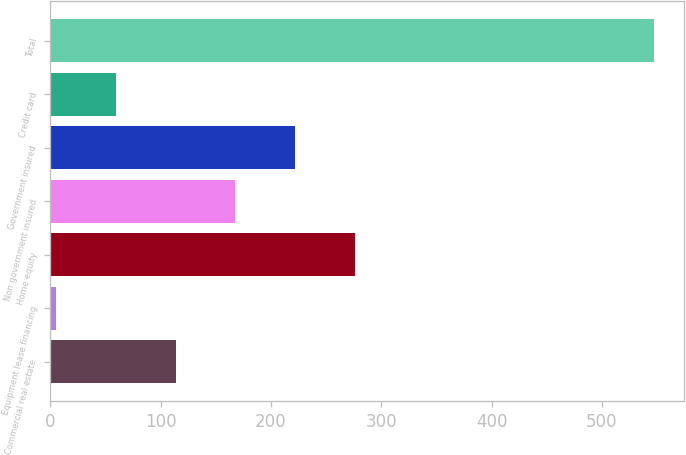Convert chart to OTSL. <chart><loc_0><loc_0><loc_500><loc_500><bar_chart><fcel>Commercial real estate<fcel>Equipment lease financing<fcel>Home equity<fcel>Non government insured<fcel>Government insured<fcel>Credit card<fcel>Total<nl><fcel>113.4<fcel>5<fcel>276<fcel>167.6<fcel>221.8<fcel>59.2<fcel>547<nl></chart> 